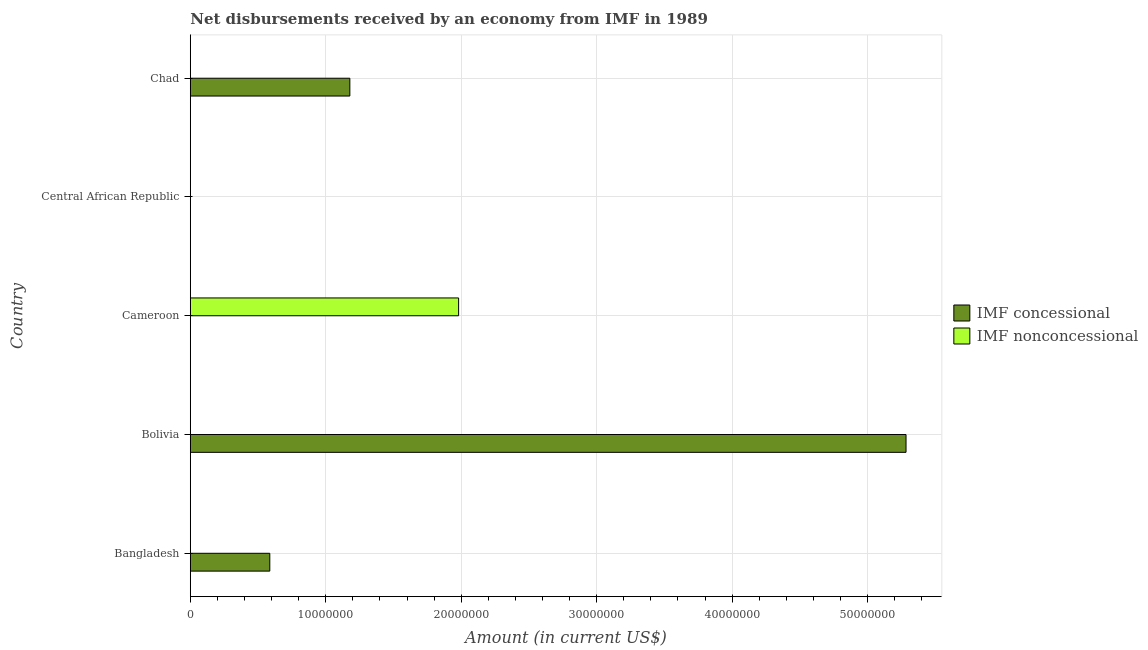How many different coloured bars are there?
Offer a terse response. 2. Are the number of bars on each tick of the Y-axis equal?
Provide a succinct answer. No. How many bars are there on the 1st tick from the top?
Your answer should be very brief. 1. How many bars are there on the 4th tick from the bottom?
Provide a short and direct response. 0. What is the label of the 3rd group of bars from the top?
Offer a very short reply. Cameroon. In how many cases, is the number of bars for a given country not equal to the number of legend labels?
Your answer should be very brief. 5. What is the net concessional disbursements from imf in Chad?
Provide a short and direct response. 1.18e+07. Across all countries, what is the maximum net concessional disbursements from imf?
Offer a very short reply. 5.28e+07. Across all countries, what is the minimum net non concessional disbursements from imf?
Your answer should be compact. 0. In which country was the net non concessional disbursements from imf maximum?
Give a very brief answer. Cameroon. What is the total net concessional disbursements from imf in the graph?
Offer a terse response. 7.05e+07. What is the difference between the net concessional disbursements from imf in Bolivia and that in Chad?
Provide a succinct answer. 4.11e+07. What is the difference between the net non concessional disbursements from imf in Central African Republic and the net concessional disbursements from imf in Bolivia?
Provide a succinct answer. -5.28e+07. What is the average net non concessional disbursements from imf per country?
Offer a very short reply. 3.96e+06. What is the ratio of the net concessional disbursements from imf in Bangladesh to that in Chad?
Keep it short and to the point. 0.5. What is the difference between the highest and the second highest net concessional disbursements from imf?
Give a very brief answer. 4.11e+07. What is the difference between the highest and the lowest net concessional disbursements from imf?
Ensure brevity in your answer.  5.28e+07. In how many countries, is the net non concessional disbursements from imf greater than the average net non concessional disbursements from imf taken over all countries?
Your answer should be compact. 1. Is the sum of the net concessional disbursements from imf in Bangladesh and Bolivia greater than the maximum net non concessional disbursements from imf across all countries?
Provide a succinct answer. Yes. How many bars are there?
Ensure brevity in your answer.  4. How many countries are there in the graph?
Your answer should be compact. 5. What is the difference between two consecutive major ticks on the X-axis?
Provide a succinct answer. 1.00e+07. Does the graph contain any zero values?
Provide a succinct answer. Yes. How are the legend labels stacked?
Make the answer very short. Vertical. What is the title of the graph?
Your response must be concise. Net disbursements received by an economy from IMF in 1989. What is the label or title of the X-axis?
Provide a succinct answer. Amount (in current US$). What is the Amount (in current US$) in IMF concessional in Bangladesh?
Give a very brief answer. 5.87e+06. What is the Amount (in current US$) of IMF concessional in Bolivia?
Make the answer very short. 5.28e+07. What is the Amount (in current US$) in IMF nonconcessional in Cameroon?
Keep it short and to the point. 1.98e+07. What is the Amount (in current US$) of IMF concessional in Central African Republic?
Offer a terse response. 0. What is the Amount (in current US$) of IMF concessional in Chad?
Provide a short and direct response. 1.18e+07. Across all countries, what is the maximum Amount (in current US$) of IMF concessional?
Offer a very short reply. 5.28e+07. Across all countries, what is the maximum Amount (in current US$) of IMF nonconcessional?
Your answer should be compact. 1.98e+07. Across all countries, what is the minimum Amount (in current US$) in IMF nonconcessional?
Make the answer very short. 0. What is the total Amount (in current US$) in IMF concessional in the graph?
Ensure brevity in your answer.  7.05e+07. What is the total Amount (in current US$) of IMF nonconcessional in the graph?
Offer a terse response. 1.98e+07. What is the difference between the Amount (in current US$) in IMF concessional in Bangladesh and that in Bolivia?
Make the answer very short. -4.70e+07. What is the difference between the Amount (in current US$) of IMF concessional in Bangladesh and that in Chad?
Your answer should be compact. -5.91e+06. What is the difference between the Amount (in current US$) of IMF concessional in Bolivia and that in Chad?
Provide a succinct answer. 4.11e+07. What is the difference between the Amount (in current US$) in IMF concessional in Bangladesh and the Amount (in current US$) in IMF nonconcessional in Cameroon?
Provide a short and direct response. -1.39e+07. What is the difference between the Amount (in current US$) of IMF concessional in Bolivia and the Amount (in current US$) of IMF nonconcessional in Cameroon?
Ensure brevity in your answer.  3.30e+07. What is the average Amount (in current US$) of IMF concessional per country?
Provide a succinct answer. 1.41e+07. What is the average Amount (in current US$) of IMF nonconcessional per country?
Your answer should be compact. 3.96e+06. What is the ratio of the Amount (in current US$) in IMF concessional in Bangladesh to that in Bolivia?
Make the answer very short. 0.11. What is the ratio of the Amount (in current US$) in IMF concessional in Bangladesh to that in Chad?
Your answer should be very brief. 0.5. What is the ratio of the Amount (in current US$) of IMF concessional in Bolivia to that in Chad?
Provide a succinct answer. 4.49. What is the difference between the highest and the second highest Amount (in current US$) in IMF concessional?
Give a very brief answer. 4.11e+07. What is the difference between the highest and the lowest Amount (in current US$) of IMF concessional?
Keep it short and to the point. 5.28e+07. What is the difference between the highest and the lowest Amount (in current US$) of IMF nonconcessional?
Provide a short and direct response. 1.98e+07. 